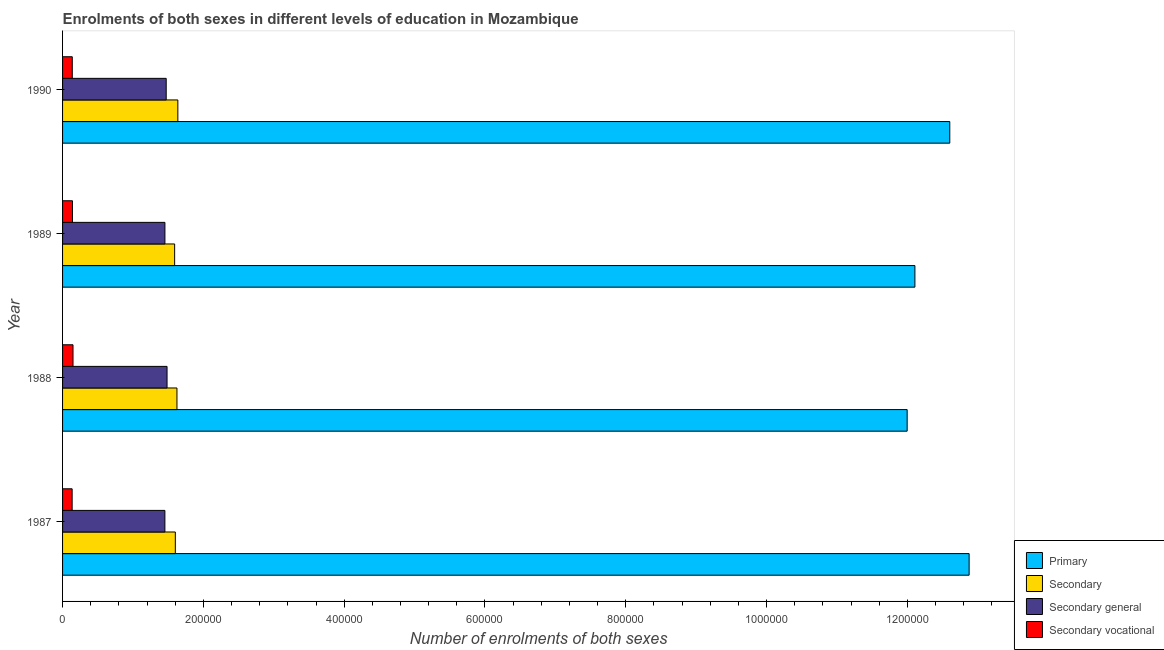How many groups of bars are there?
Give a very brief answer. 4. How many bars are there on the 3rd tick from the top?
Keep it short and to the point. 4. How many bars are there on the 4th tick from the bottom?
Give a very brief answer. 4. What is the label of the 1st group of bars from the top?
Your answer should be compact. 1990. In how many cases, is the number of bars for a given year not equal to the number of legend labels?
Provide a short and direct response. 0. What is the number of enrolments in secondary vocational education in 1989?
Provide a short and direct response. 1.41e+04. Across all years, what is the maximum number of enrolments in primary education?
Offer a terse response. 1.29e+06. Across all years, what is the minimum number of enrolments in secondary general education?
Ensure brevity in your answer.  1.45e+05. In which year was the number of enrolments in secondary vocational education minimum?
Your answer should be very brief. 1987. What is the total number of enrolments in primary education in the graph?
Give a very brief answer. 4.96e+06. What is the difference between the number of enrolments in primary education in 1988 and that in 1990?
Your response must be concise. -6.05e+04. What is the difference between the number of enrolments in secondary general education in 1987 and the number of enrolments in primary education in 1989?
Offer a very short reply. -1.07e+06. What is the average number of enrolments in secondary vocational education per year?
Ensure brevity in your answer.  1.41e+04. In the year 1988, what is the difference between the number of enrolments in secondary education and number of enrolments in secondary vocational education?
Offer a terse response. 1.48e+05. In how many years, is the number of enrolments in secondary education greater than 600000 ?
Provide a succinct answer. 0. Is the difference between the number of enrolments in secondary vocational education in 1988 and 1990 greater than the difference between the number of enrolments in primary education in 1988 and 1990?
Offer a very short reply. Yes. What is the difference between the highest and the second highest number of enrolments in secondary vocational education?
Provide a short and direct response. 759. What is the difference between the highest and the lowest number of enrolments in secondary vocational education?
Provide a short and direct response. 1230. In how many years, is the number of enrolments in secondary general education greater than the average number of enrolments in secondary general education taken over all years?
Provide a succinct answer. 2. Is it the case that in every year, the sum of the number of enrolments in secondary vocational education and number of enrolments in secondary education is greater than the sum of number of enrolments in secondary general education and number of enrolments in primary education?
Ensure brevity in your answer.  No. What does the 1st bar from the top in 1987 represents?
Make the answer very short. Secondary vocational. What does the 4th bar from the bottom in 1988 represents?
Your answer should be compact. Secondary vocational. Is it the case that in every year, the sum of the number of enrolments in primary education and number of enrolments in secondary education is greater than the number of enrolments in secondary general education?
Make the answer very short. Yes. Are all the bars in the graph horizontal?
Your answer should be very brief. Yes. Does the graph contain grids?
Provide a succinct answer. No. How are the legend labels stacked?
Provide a short and direct response. Vertical. What is the title of the graph?
Give a very brief answer. Enrolments of both sexes in different levels of education in Mozambique. Does "Building human resources" appear as one of the legend labels in the graph?
Give a very brief answer. No. What is the label or title of the X-axis?
Keep it short and to the point. Number of enrolments of both sexes. What is the label or title of the Y-axis?
Your answer should be very brief. Year. What is the Number of enrolments of both sexes of Primary in 1987?
Keep it short and to the point. 1.29e+06. What is the Number of enrolments of both sexes in Secondary in 1987?
Offer a terse response. 1.60e+05. What is the Number of enrolments of both sexes in Secondary general in 1987?
Provide a short and direct response. 1.45e+05. What is the Number of enrolments of both sexes in Secondary vocational in 1987?
Ensure brevity in your answer.  1.36e+04. What is the Number of enrolments of both sexes in Primary in 1988?
Provide a succinct answer. 1.20e+06. What is the Number of enrolments of both sexes in Secondary in 1988?
Your answer should be compact. 1.62e+05. What is the Number of enrolments of both sexes of Secondary general in 1988?
Your answer should be very brief. 1.48e+05. What is the Number of enrolments of both sexes of Secondary vocational in 1988?
Your answer should be compact. 1.48e+04. What is the Number of enrolments of both sexes of Primary in 1989?
Keep it short and to the point. 1.21e+06. What is the Number of enrolments of both sexes of Secondary in 1989?
Ensure brevity in your answer.  1.59e+05. What is the Number of enrolments of both sexes of Secondary general in 1989?
Your answer should be very brief. 1.45e+05. What is the Number of enrolments of both sexes in Secondary vocational in 1989?
Your answer should be very brief. 1.41e+04. What is the Number of enrolments of both sexes of Primary in 1990?
Provide a short and direct response. 1.26e+06. What is the Number of enrolments of both sexes of Secondary in 1990?
Ensure brevity in your answer.  1.64e+05. What is the Number of enrolments of both sexes of Secondary general in 1990?
Provide a short and direct response. 1.47e+05. What is the Number of enrolments of both sexes of Secondary vocational in 1990?
Make the answer very short. 1.38e+04. Across all years, what is the maximum Number of enrolments of both sexes in Primary?
Offer a terse response. 1.29e+06. Across all years, what is the maximum Number of enrolments of both sexes of Secondary?
Offer a very short reply. 1.64e+05. Across all years, what is the maximum Number of enrolments of both sexes of Secondary general?
Offer a very short reply. 1.48e+05. Across all years, what is the maximum Number of enrolments of both sexes in Secondary vocational?
Offer a very short reply. 1.48e+04. Across all years, what is the minimum Number of enrolments of both sexes of Primary?
Provide a succinct answer. 1.20e+06. Across all years, what is the minimum Number of enrolments of both sexes in Secondary?
Your response must be concise. 1.59e+05. Across all years, what is the minimum Number of enrolments of both sexes of Secondary general?
Give a very brief answer. 1.45e+05. Across all years, what is the minimum Number of enrolments of both sexes in Secondary vocational?
Ensure brevity in your answer.  1.36e+04. What is the total Number of enrolments of both sexes of Primary in the graph?
Your answer should be compact. 4.96e+06. What is the total Number of enrolments of both sexes in Secondary in the graph?
Offer a very short reply. 6.46e+05. What is the total Number of enrolments of both sexes in Secondary general in the graph?
Offer a very short reply. 5.86e+05. What is the total Number of enrolments of both sexes of Secondary vocational in the graph?
Your response must be concise. 5.63e+04. What is the difference between the Number of enrolments of both sexes of Primary in 1987 and that in 1988?
Offer a very short reply. 8.80e+04. What is the difference between the Number of enrolments of both sexes in Secondary in 1987 and that in 1988?
Give a very brief answer. -2309. What is the difference between the Number of enrolments of both sexes of Secondary general in 1987 and that in 1988?
Provide a short and direct response. -3068. What is the difference between the Number of enrolments of both sexes of Secondary vocational in 1987 and that in 1988?
Provide a succinct answer. -1230. What is the difference between the Number of enrolments of both sexes of Primary in 1987 and that in 1989?
Your answer should be very brief. 7.70e+04. What is the difference between the Number of enrolments of both sexes of Secondary in 1987 and that in 1989?
Provide a short and direct response. 975. What is the difference between the Number of enrolments of both sexes of Secondary general in 1987 and that in 1989?
Keep it short and to the point. -57. What is the difference between the Number of enrolments of both sexes in Secondary vocational in 1987 and that in 1989?
Provide a succinct answer. -471. What is the difference between the Number of enrolments of both sexes in Primary in 1987 and that in 1990?
Your answer should be compact. 2.75e+04. What is the difference between the Number of enrolments of both sexes of Secondary in 1987 and that in 1990?
Your answer should be very brief. -3570. What is the difference between the Number of enrolments of both sexes in Secondary general in 1987 and that in 1990?
Provide a succinct answer. -1860. What is the difference between the Number of enrolments of both sexes of Secondary vocational in 1987 and that in 1990?
Keep it short and to the point. -198. What is the difference between the Number of enrolments of both sexes in Primary in 1988 and that in 1989?
Your answer should be very brief. -1.10e+04. What is the difference between the Number of enrolments of both sexes in Secondary in 1988 and that in 1989?
Your answer should be compact. 3284. What is the difference between the Number of enrolments of both sexes in Secondary general in 1988 and that in 1989?
Your answer should be very brief. 3011. What is the difference between the Number of enrolments of both sexes of Secondary vocational in 1988 and that in 1989?
Make the answer very short. 759. What is the difference between the Number of enrolments of both sexes of Primary in 1988 and that in 1990?
Provide a short and direct response. -6.05e+04. What is the difference between the Number of enrolments of both sexes in Secondary in 1988 and that in 1990?
Offer a very short reply. -1261. What is the difference between the Number of enrolments of both sexes in Secondary general in 1988 and that in 1990?
Provide a succinct answer. 1208. What is the difference between the Number of enrolments of both sexes in Secondary vocational in 1988 and that in 1990?
Make the answer very short. 1032. What is the difference between the Number of enrolments of both sexes in Primary in 1989 and that in 1990?
Your answer should be compact. -4.95e+04. What is the difference between the Number of enrolments of both sexes of Secondary in 1989 and that in 1990?
Provide a succinct answer. -4545. What is the difference between the Number of enrolments of both sexes in Secondary general in 1989 and that in 1990?
Make the answer very short. -1803. What is the difference between the Number of enrolments of both sexes of Secondary vocational in 1989 and that in 1990?
Make the answer very short. 273. What is the difference between the Number of enrolments of both sexes of Primary in 1987 and the Number of enrolments of both sexes of Secondary in 1988?
Your answer should be very brief. 1.13e+06. What is the difference between the Number of enrolments of both sexes of Primary in 1987 and the Number of enrolments of both sexes of Secondary general in 1988?
Provide a short and direct response. 1.14e+06. What is the difference between the Number of enrolments of both sexes of Primary in 1987 and the Number of enrolments of both sexes of Secondary vocational in 1988?
Offer a terse response. 1.27e+06. What is the difference between the Number of enrolments of both sexes of Secondary in 1987 and the Number of enrolments of both sexes of Secondary general in 1988?
Provide a short and direct response. 1.18e+04. What is the difference between the Number of enrolments of both sexes in Secondary in 1987 and the Number of enrolments of both sexes in Secondary vocational in 1988?
Ensure brevity in your answer.  1.45e+05. What is the difference between the Number of enrolments of both sexes in Secondary general in 1987 and the Number of enrolments of both sexes in Secondary vocational in 1988?
Offer a terse response. 1.31e+05. What is the difference between the Number of enrolments of both sexes of Primary in 1987 and the Number of enrolments of both sexes of Secondary in 1989?
Offer a very short reply. 1.13e+06. What is the difference between the Number of enrolments of both sexes of Primary in 1987 and the Number of enrolments of both sexes of Secondary general in 1989?
Give a very brief answer. 1.14e+06. What is the difference between the Number of enrolments of both sexes of Primary in 1987 and the Number of enrolments of both sexes of Secondary vocational in 1989?
Your answer should be very brief. 1.27e+06. What is the difference between the Number of enrolments of both sexes of Secondary in 1987 and the Number of enrolments of both sexes of Secondary general in 1989?
Provide a short and direct response. 1.48e+04. What is the difference between the Number of enrolments of both sexes in Secondary in 1987 and the Number of enrolments of both sexes in Secondary vocational in 1989?
Ensure brevity in your answer.  1.46e+05. What is the difference between the Number of enrolments of both sexes of Secondary general in 1987 and the Number of enrolments of both sexes of Secondary vocational in 1989?
Ensure brevity in your answer.  1.31e+05. What is the difference between the Number of enrolments of both sexes of Primary in 1987 and the Number of enrolments of both sexes of Secondary in 1990?
Offer a terse response. 1.12e+06. What is the difference between the Number of enrolments of both sexes in Primary in 1987 and the Number of enrolments of both sexes in Secondary general in 1990?
Offer a terse response. 1.14e+06. What is the difference between the Number of enrolments of both sexes in Primary in 1987 and the Number of enrolments of both sexes in Secondary vocational in 1990?
Offer a terse response. 1.27e+06. What is the difference between the Number of enrolments of both sexes in Secondary in 1987 and the Number of enrolments of both sexes in Secondary general in 1990?
Keep it short and to the point. 1.30e+04. What is the difference between the Number of enrolments of both sexes in Secondary in 1987 and the Number of enrolments of both sexes in Secondary vocational in 1990?
Your answer should be compact. 1.46e+05. What is the difference between the Number of enrolments of both sexes of Secondary general in 1987 and the Number of enrolments of both sexes of Secondary vocational in 1990?
Offer a terse response. 1.32e+05. What is the difference between the Number of enrolments of both sexes in Primary in 1988 and the Number of enrolments of both sexes in Secondary in 1989?
Ensure brevity in your answer.  1.04e+06. What is the difference between the Number of enrolments of both sexes in Primary in 1988 and the Number of enrolments of both sexes in Secondary general in 1989?
Provide a succinct answer. 1.05e+06. What is the difference between the Number of enrolments of both sexes of Primary in 1988 and the Number of enrolments of both sexes of Secondary vocational in 1989?
Provide a short and direct response. 1.19e+06. What is the difference between the Number of enrolments of both sexes of Secondary in 1988 and the Number of enrolments of both sexes of Secondary general in 1989?
Ensure brevity in your answer.  1.71e+04. What is the difference between the Number of enrolments of both sexes of Secondary in 1988 and the Number of enrolments of both sexes of Secondary vocational in 1989?
Your answer should be compact. 1.48e+05. What is the difference between the Number of enrolments of both sexes in Secondary general in 1988 and the Number of enrolments of both sexes in Secondary vocational in 1989?
Your response must be concise. 1.34e+05. What is the difference between the Number of enrolments of both sexes of Primary in 1988 and the Number of enrolments of both sexes of Secondary in 1990?
Provide a succinct answer. 1.04e+06. What is the difference between the Number of enrolments of both sexes of Primary in 1988 and the Number of enrolments of both sexes of Secondary general in 1990?
Offer a terse response. 1.05e+06. What is the difference between the Number of enrolments of both sexes of Primary in 1988 and the Number of enrolments of both sexes of Secondary vocational in 1990?
Ensure brevity in your answer.  1.19e+06. What is the difference between the Number of enrolments of both sexes of Secondary in 1988 and the Number of enrolments of both sexes of Secondary general in 1990?
Your answer should be compact. 1.53e+04. What is the difference between the Number of enrolments of both sexes in Secondary in 1988 and the Number of enrolments of both sexes in Secondary vocational in 1990?
Give a very brief answer. 1.49e+05. What is the difference between the Number of enrolments of both sexes in Secondary general in 1988 and the Number of enrolments of both sexes in Secondary vocational in 1990?
Make the answer very short. 1.35e+05. What is the difference between the Number of enrolments of both sexes of Primary in 1989 and the Number of enrolments of both sexes of Secondary in 1990?
Your response must be concise. 1.05e+06. What is the difference between the Number of enrolments of both sexes of Primary in 1989 and the Number of enrolments of both sexes of Secondary general in 1990?
Your answer should be compact. 1.06e+06. What is the difference between the Number of enrolments of both sexes in Primary in 1989 and the Number of enrolments of both sexes in Secondary vocational in 1990?
Your answer should be compact. 1.20e+06. What is the difference between the Number of enrolments of both sexes of Secondary in 1989 and the Number of enrolments of both sexes of Secondary general in 1990?
Your response must be concise. 1.20e+04. What is the difference between the Number of enrolments of both sexes in Secondary in 1989 and the Number of enrolments of both sexes in Secondary vocational in 1990?
Offer a very short reply. 1.45e+05. What is the difference between the Number of enrolments of both sexes in Secondary general in 1989 and the Number of enrolments of both sexes in Secondary vocational in 1990?
Offer a terse response. 1.32e+05. What is the average Number of enrolments of both sexes in Primary per year?
Ensure brevity in your answer.  1.24e+06. What is the average Number of enrolments of both sexes in Secondary per year?
Your response must be concise. 1.61e+05. What is the average Number of enrolments of both sexes in Secondary general per year?
Ensure brevity in your answer.  1.47e+05. What is the average Number of enrolments of both sexes in Secondary vocational per year?
Make the answer very short. 1.41e+04. In the year 1987, what is the difference between the Number of enrolments of both sexes in Primary and Number of enrolments of both sexes in Secondary?
Ensure brevity in your answer.  1.13e+06. In the year 1987, what is the difference between the Number of enrolments of both sexes of Primary and Number of enrolments of both sexes of Secondary general?
Ensure brevity in your answer.  1.14e+06. In the year 1987, what is the difference between the Number of enrolments of both sexes in Primary and Number of enrolments of both sexes in Secondary vocational?
Your answer should be very brief. 1.27e+06. In the year 1987, what is the difference between the Number of enrolments of both sexes of Secondary and Number of enrolments of both sexes of Secondary general?
Keep it short and to the point. 1.48e+04. In the year 1987, what is the difference between the Number of enrolments of both sexes in Secondary and Number of enrolments of both sexes in Secondary vocational?
Make the answer very short. 1.47e+05. In the year 1987, what is the difference between the Number of enrolments of both sexes of Secondary general and Number of enrolments of both sexes of Secondary vocational?
Your answer should be very brief. 1.32e+05. In the year 1988, what is the difference between the Number of enrolments of both sexes of Primary and Number of enrolments of both sexes of Secondary?
Offer a terse response. 1.04e+06. In the year 1988, what is the difference between the Number of enrolments of both sexes in Primary and Number of enrolments of both sexes in Secondary general?
Offer a very short reply. 1.05e+06. In the year 1988, what is the difference between the Number of enrolments of both sexes in Primary and Number of enrolments of both sexes in Secondary vocational?
Offer a terse response. 1.18e+06. In the year 1988, what is the difference between the Number of enrolments of both sexes in Secondary and Number of enrolments of both sexes in Secondary general?
Your response must be concise. 1.41e+04. In the year 1988, what is the difference between the Number of enrolments of both sexes in Secondary and Number of enrolments of both sexes in Secondary vocational?
Offer a terse response. 1.48e+05. In the year 1988, what is the difference between the Number of enrolments of both sexes of Secondary general and Number of enrolments of both sexes of Secondary vocational?
Offer a very short reply. 1.34e+05. In the year 1989, what is the difference between the Number of enrolments of both sexes of Primary and Number of enrolments of both sexes of Secondary?
Offer a terse response. 1.05e+06. In the year 1989, what is the difference between the Number of enrolments of both sexes in Primary and Number of enrolments of both sexes in Secondary general?
Your response must be concise. 1.07e+06. In the year 1989, what is the difference between the Number of enrolments of both sexes in Primary and Number of enrolments of both sexes in Secondary vocational?
Offer a very short reply. 1.20e+06. In the year 1989, what is the difference between the Number of enrolments of both sexes of Secondary and Number of enrolments of both sexes of Secondary general?
Provide a short and direct response. 1.38e+04. In the year 1989, what is the difference between the Number of enrolments of both sexes of Secondary and Number of enrolments of both sexes of Secondary vocational?
Provide a short and direct response. 1.45e+05. In the year 1989, what is the difference between the Number of enrolments of both sexes of Secondary general and Number of enrolments of both sexes of Secondary vocational?
Make the answer very short. 1.31e+05. In the year 1990, what is the difference between the Number of enrolments of both sexes in Primary and Number of enrolments of both sexes in Secondary?
Your answer should be very brief. 1.10e+06. In the year 1990, what is the difference between the Number of enrolments of both sexes of Primary and Number of enrolments of both sexes of Secondary general?
Offer a very short reply. 1.11e+06. In the year 1990, what is the difference between the Number of enrolments of both sexes in Primary and Number of enrolments of both sexes in Secondary vocational?
Offer a terse response. 1.25e+06. In the year 1990, what is the difference between the Number of enrolments of both sexes of Secondary and Number of enrolments of both sexes of Secondary general?
Offer a very short reply. 1.65e+04. In the year 1990, what is the difference between the Number of enrolments of both sexes of Secondary and Number of enrolments of both sexes of Secondary vocational?
Give a very brief answer. 1.50e+05. In the year 1990, what is the difference between the Number of enrolments of both sexes of Secondary general and Number of enrolments of both sexes of Secondary vocational?
Give a very brief answer. 1.33e+05. What is the ratio of the Number of enrolments of both sexes of Primary in 1987 to that in 1988?
Give a very brief answer. 1.07. What is the ratio of the Number of enrolments of both sexes of Secondary in 1987 to that in 1988?
Provide a short and direct response. 0.99. What is the ratio of the Number of enrolments of both sexes of Secondary general in 1987 to that in 1988?
Offer a very short reply. 0.98. What is the ratio of the Number of enrolments of both sexes of Secondary vocational in 1987 to that in 1988?
Ensure brevity in your answer.  0.92. What is the ratio of the Number of enrolments of both sexes in Primary in 1987 to that in 1989?
Your response must be concise. 1.06. What is the ratio of the Number of enrolments of both sexes of Secondary in 1987 to that in 1989?
Ensure brevity in your answer.  1.01. What is the ratio of the Number of enrolments of both sexes in Secondary vocational in 1987 to that in 1989?
Provide a short and direct response. 0.97. What is the ratio of the Number of enrolments of both sexes in Primary in 1987 to that in 1990?
Your response must be concise. 1.02. What is the ratio of the Number of enrolments of both sexes of Secondary in 1987 to that in 1990?
Your answer should be very brief. 0.98. What is the ratio of the Number of enrolments of both sexes of Secondary general in 1987 to that in 1990?
Offer a very short reply. 0.99. What is the ratio of the Number of enrolments of both sexes of Secondary vocational in 1987 to that in 1990?
Offer a terse response. 0.99. What is the ratio of the Number of enrolments of both sexes of Primary in 1988 to that in 1989?
Provide a succinct answer. 0.99. What is the ratio of the Number of enrolments of both sexes of Secondary in 1988 to that in 1989?
Your answer should be very brief. 1.02. What is the ratio of the Number of enrolments of both sexes of Secondary general in 1988 to that in 1989?
Your response must be concise. 1.02. What is the ratio of the Number of enrolments of both sexes in Secondary vocational in 1988 to that in 1989?
Ensure brevity in your answer.  1.05. What is the ratio of the Number of enrolments of both sexes in Secondary general in 1988 to that in 1990?
Offer a terse response. 1.01. What is the ratio of the Number of enrolments of both sexes of Secondary vocational in 1988 to that in 1990?
Make the answer very short. 1.07. What is the ratio of the Number of enrolments of both sexes of Primary in 1989 to that in 1990?
Make the answer very short. 0.96. What is the ratio of the Number of enrolments of both sexes of Secondary in 1989 to that in 1990?
Your response must be concise. 0.97. What is the ratio of the Number of enrolments of both sexes of Secondary general in 1989 to that in 1990?
Provide a succinct answer. 0.99. What is the ratio of the Number of enrolments of both sexes in Secondary vocational in 1989 to that in 1990?
Your response must be concise. 1.02. What is the difference between the highest and the second highest Number of enrolments of both sexes in Primary?
Your answer should be very brief. 2.75e+04. What is the difference between the highest and the second highest Number of enrolments of both sexes of Secondary?
Your answer should be compact. 1261. What is the difference between the highest and the second highest Number of enrolments of both sexes of Secondary general?
Your answer should be very brief. 1208. What is the difference between the highest and the second highest Number of enrolments of both sexes of Secondary vocational?
Your answer should be very brief. 759. What is the difference between the highest and the lowest Number of enrolments of both sexes of Primary?
Offer a very short reply. 8.80e+04. What is the difference between the highest and the lowest Number of enrolments of both sexes of Secondary?
Provide a succinct answer. 4545. What is the difference between the highest and the lowest Number of enrolments of both sexes of Secondary general?
Provide a succinct answer. 3068. What is the difference between the highest and the lowest Number of enrolments of both sexes in Secondary vocational?
Offer a terse response. 1230. 